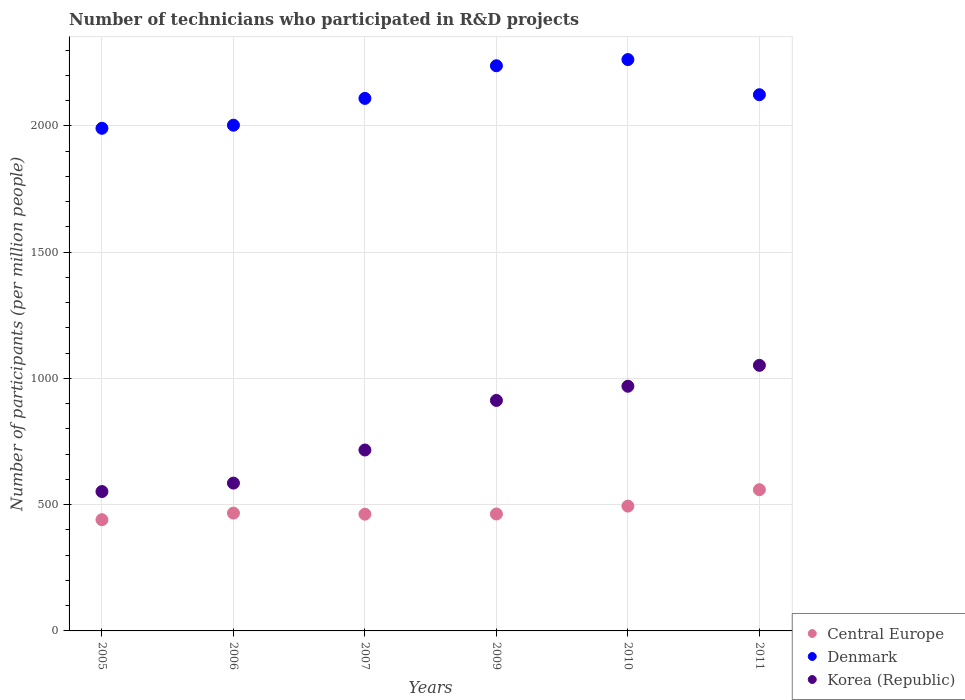How many different coloured dotlines are there?
Offer a terse response. 3. Is the number of dotlines equal to the number of legend labels?
Your response must be concise. Yes. What is the number of technicians who participated in R&D projects in Central Europe in 2006?
Keep it short and to the point. 466.5. Across all years, what is the maximum number of technicians who participated in R&D projects in Denmark?
Make the answer very short. 2262.1. Across all years, what is the minimum number of technicians who participated in R&D projects in Korea (Republic)?
Provide a succinct answer. 551.85. In which year was the number of technicians who participated in R&D projects in Denmark maximum?
Give a very brief answer. 2010. In which year was the number of technicians who participated in R&D projects in Korea (Republic) minimum?
Your answer should be very brief. 2005. What is the total number of technicians who participated in R&D projects in Korea (Republic) in the graph?
Your answer should be very brief. 4786.26. What is the difference between the number of technicians who participated in R&D projects in Korea (Republic) in 2005 and that in 2006?
Provide a succinct answer. -33.42. What is the difference between the number of technicians who participated in R&D projects in Central Europe in 2007 and the number of technicians who participated in R&D projects in Korea (Republic) in 2009?
Provide a short and direct response. -450.33. What is the average number of technicians who participated in R&D projects in Korea (Republic) per year?
Make the answer very short. 797.71. In the year 2006, what is the difference between the number of technicians who participated in R&D projects in Denmark and number of technicians who participated in R&D projects in Korea (Republic)?
Make the answer very short. 1417.02. What is the ratio of the number of technicians who participated in R&D projects in Central Europe in 2006 to that in 2009?
Your response must be concise. 1.01. Is the number of technicians who participated in R&D projects in Central Europe in 2005 less than that in 2009?
Ensure brevity in your answer.  Yes. What is the difference between the highest and the second highest number of technicians who participated in R&D projects in Denmark?
Make the answer very short. 24.47. What is the difference between the highest and the lowest number of technicians who participated in R&D projects in Central Europe?
Offer a terse response. 118.71. Is the sum of the number of technicians who participated in R&D projects in Korea (Republic) in 2007 and 2011 greater than the maximum number of technicians who participated in R&D projects in Denmark across all years?
Make the answer very short. No. Is the number of technicians who participated in R&D projects in Korea (Republic) strictly less than the number of technicians who participated in R&D projects in Denmark over the years?
Give a very brief answer. Yes. How many dotlines are there?
Your answer should be very brief. 3. How many years are there in the graph?
Offer a terse response. 6. What is the difference between two consecutive major ticks on the Y-axis?
Make the answer very short. 500. Does the graph contain any zero values?
Ensure brevity in your answer.  No. Does the graph contain grids?
Provide a short and direct response. Yes. Where does the legend appear in the graph?
Your answer should be very brief. Bottom right. How are the legend labels stacked?
Your answer should be very brief. Vertical. What is the title of the graph?
Your answer should be compact. Number of technicians who participated in R&D projects. Does "South Asia" appear as one of the legend labels in the graph?
Offer a terse response. No. What is the label or title of the Y-axis?
Give a very brief answer. Number of participants (per million people). What is the Number of participants (per million people) in Central Europe in 2005?
Make the answer very short. 440.38. What is the Number of participants (per million people) in Denmark in 2005?
Your answer should be compact. 1990.05. What is the Number of participants (per million people) of Korea (Republic) in 2005?
Ensure brevity in your answer.  551.85. What is the Number of participants (per million people) in Central Europe in 2006?
Provide a succinct answer. 466.5. What is the Number of participants (per million people) in Denmark in 2006?
Your response must be concise. 2002.29. What is the Number of participants (per million people) of Korea (Republic) in 2006?
Your response must be concise. 585.27. What is the Number of participants (per million people) in Central Europe in 2007?
Offer a terse response. 462.27. What is the Number of participants (per million people) of Denmark in 2007?
Your response must be concise. 2108.42. What is the Number of participants (per million people) of Korea (Republic) in 2007?
Provide a succinct answer. 716.3. What is the Number of participants (per million people) of Central Europe in 2009?
Offer a very short reply. 463.02. What is the Number of participants (per million people) in Denmark in 2009?
Make the answer very short. 2237.63. What is the Number of participants (per million people) of Korea (Republic) in 2009?
Give a very brief answer. 912.6. What is the Number of participants (per million people) in Central Europe in 2010?
Make the answer very short. 494.17. What is the Number of participants (per million people) of Denmark in 2010?
Offer a terse response. 2262.1. What is the Number of participants (per million people) of Korea (Republic) in 2010?
Your answer should be compact. 968.76. What is the Number of participants (per million people) in Central Europe in 2011?
Offer a very short reply. 559.09. What is the Number of participants (per million people) in Denmark in 2011?
Give a very brief answer. 2122.99. What is the Number of participants (per million people) in Korea (Republic) in 2011?
Ensure brevity in your answer.  1051.47. Across all years, what is the maximum Number of participants (per million people) of Central Europe?
Offer a very short reply. 559.09. Across all years, what is the maximum Number of participants (per million people) of Denmark?
Your answer should be very brief. 2262.1. Across all years, what is the maximum Number of participants (per million people) of Korea (Republic)?
Offer a terse response. 1051.47. Across all years, what is the minimum Number of participants (per million people) of Central Europe?
Give a very brief answer. 440.38. Across all years, what is the minimum Number of participants (per million people) of Denmark?
Your answer should be compact. 1990.05. Across all years, what is the minimum Number of participants (per million people) of Korea (Republic)?
Offer a terse response. 551.85. What is the total Number of participants (per million people) in Central Europe in the graph?
Keep it short and to the point. 2885.44. What is the total Number of participants (per million people) in Denmark in the graph?
Your response must be concise. 1.27e+04. What is the total Number of participants (per million people) of Korea (Republic) in the graph?
Offer a terse response. 4786.26. What is the difference between the Number of participants (per million people) of Central Europe in 2005 and that in 2006?
Your answer should be very brief. -26.13. What is the difference between the Number of participants (per million people) in Denmark in 2005 and that in 2006?
Offer a terse response. -12.24. What is the difference between the Number of participants (per million people) in Korea (Republic) in 2005 and that in 2006?
Ensure brevity in your answer.  -33.42. What is the difference between the Number of participants (per million people) of Central Europe in 2005 and that in 2007?
Ensure brevity in your answer.  -21.9. What is the difference between the Number of participants (per million people) in Denmark in 2005 and that in 2007?
Your response must be concise. -118.37. What is the difference between the Number of participants (per million people) of Korea (Republic) in 2005 and that in 2007?
Make the answer very short. -164.45. What is the difference between the Number of participants (per million people) in Central Europe in 2005 and that in 2009?
Your answer should be compact. -22.64. What is the difference between the Number of participants (per million people) of Denmark in 2005 and that in 2009?
Offer a very short reply. -247.57. What is the difference between the Number of participants (per million people) of Korea (Republic) in 2005 and that in 2009?
Ensure brevity in your answer.  -360.74. What is the difference between the Number of participants (per million people) in Central Europe in 2005 and that in 2010?
Keep it short and to the point. -53.79. What is the difference between the Number of participants (per million people) in Denmark in 2005 and that in 2010?
Make the answer very short. -272.04. What is the difference between the Number of participants (per million people) in Korea (Republic) in 2005 and that in 2010?
Your response must be concise. -416.91. What is the difference between the Number of participants (per million people) of Central Europe in 2005 and that in 2011?
Ensure brevity in your answer.  -118.71. What is the difference between the Number of participants (per million people) of Denmark in 2005 and that in 2011?
Give a very brief answer. -132.93. What is the difference between the Number of participants (per million people) of Korea (Republic) in 2005 and that in 2011?
Give a very brief answer. -499.62. What is the difference between the Number of participants (per million people) in Central Europe in 2006 and that in 2007?
Offer a very short reply. 4.23. What is the difference between the Number of participants (per million people) of Denmark in 2006 and that in 2007?
Offer a terse response. -106.13. What is the difference between the Number of participants (per million people) of Korea (Republic) in 2006 and that in 2007?
Make the answer very short. -131.03. What is the difference between the Number of participants (per million people) of Central Europe in 2006 and that in 2009?
Make the answer very short. 3.48. What is the difference between the Number of participants (per million people) in Denmark in 2006 and that in 2009?
Keep it short and to the point. -235.33. What is the difference between the Number of participants (per million people) in Korea (Republic) in 2006 and that in 2009?
Give a very brief answer. -327.33. What is the difference between the Number of participants (per million people) in Central Europe in 2006 and that in 2010?
Provide a short and direct response. -27.67. What is the difference between the Number of participants (per million people) in Denmark in 2006 and that in 2010?
Provide a succinct answer. -259.8. What is the difference between the Number of participants (per million people) in Korea (Republic) in 2006 and that in 2010?
Offer a very short reply. -383.49. What is the difference between the Number of participants (per million people) of Central Europe in 2006 and that in 2011?
Provide a short and direct response. -92.58. What is the difference between the Number of participants (per million people) of Denmark in 2006 and that in 2011?
Ensure brevity in your answer.  -120.69. What is the difference between the Number of participants (per million people) of Korea (Republic) in 2006 and that in 2011?
Give a very brief answer. -466.2. What is the difference between the Number of participants (per million people) in Central Europe in 2007 and that in 2009?
Ensure brevity in your answer.  -0.75. What is the difference between the Number of participants (per million people) of Denmark in 2007 and that in 2009?
Your response must be concise. -129.21. What is the difference between the Number of participants (per million people) in Korea (Republic) in 2007 and that in 2009?
Your answer should be compact. -196.3. What is the difference between the Number of participants (per million people) in Central Europe in 2007 and that in 2010?
Provide a short and direct response. -31.9. What is the difference between the Number of participants (per million people) of Denmark in 2007 and that in 2010?
Make the answer very short. -153.68. What is the difference between the Number of participants (per million people) of Korea (Republic) in 2007 and that in 2010?
Provide a short and direct response. -252.46. What is the difference between the Number of participants (per million people) of Central Europe in 2007 and that in 2011?
Make the answer very short. -96.82. What is the difference between the Number of participants (per million people) in Denmark in 2007 and that in 2011?
Provide a succinct answer. -14.57. What is the difference between the Number of participants (per million people) of Korea (Republic) in 2007 and that in 2011?
Ensure brevity in your answer.  -335.17. What is the difference between the Number of participants (per million people) in Central Europe in 2009 and that in 2010?
Provide a succinct answer. -31.15. What is the difference between the Number of participants (per million people) of Denmark in 2009 and that in 2010?
Offer a very short reply. -24.47. What is the difference between the Number of participants (per million people) in Korea (Republic) in 2009 and that in 2010?
Provide a short and direct response. -56.16. What is the difference between the Number of participants (per million people) of Central Europe in 2009 and that in 2011?
Your answer should be compact. -96.07. What is the difference between the Number of participants (per million people) in Denmark in 2009 and that in 2011?
Make the answer very short. 114.64. What is the difference between the Number of participants (per million people) in Korea (Republic) in 2009 and that in 2011?
Make the answer very short. -138.87. What is the difference between the Number of participants (per million people) in Central Europe in 2010 and that in 2011?
Provide a succinct answer. -64.92. What is the difference between the Number of participants (per million people) of Denmark in 2010 and that in 2011?
Provide a succinct answer. 139.11. What is the difference between the Number of participants (per million people) in Korea (Republic) in 2010 and that in 2011?
Provide a short and direct response. -82.71. What is the difference between the Number of participants (per million people) in Central Europe in 2005 and the Number of participants (per million people) in Denmark in 2006?
Your answer should be compact. -1561.91. What is the difference between the Number of participants (per million people) of Central Europe in 2005 and the Number of participants (per million people) of Korea (Republic) in 2006?
Your answer should be compact. -144.9. What is the difference between the Number of participants (per million people) of Denmark in 2005 and the Number of participants (per million people) of Korea (Republic) in 2006?
Ensure brevity in your answer.  1404.78. What is the difference between the Number of participants (per million people) of Central Europe in 2005 and the Number of participants (per million people) of Denmark in 2007?
Ensure brevity in your answer.  -1668.04. What is the difference between the Number of participants (per million people) in Central Europe in 2005 and the Number of participants (per million people) in Korea (Republic) in 2007?
Offer a terse response. -275.92. What is the difference between the Number of participants (per million people) of Denmark in 2005 and the Number of participants (per million people) of Korea (Republic) in 2007?
Offer a very short reply. 1273.75. What is the difference between the Number of participants (per million people) in Central Europe in 2005 and the Number of participants (per million people) in Denmark in 2009?
Give a very brief answer. -1797.25. What is the difference between the Number of participants (per million people) in Central Europe in 2005 and the Number of participants (per million people) in Korea (Republic) in 2009?
Make the answer very short. -472.22. What is the difference between the Number of participants (per million people) of Denmark in 2005 and the Number of participants (per million people) of Korea (Republic) in 2009?
Offer a terse response. 1077.45. What is the difference between the Number of participants (per million people) of Central Europe in 2005 and the Number of participants (per million people) of Denmark in 2010?
Your answer should be very brief. -1821.72. What is the difference between the Number of participants (per million people) in Central Europe in 2005 and the Number of participants (per million people) in Korea (Republic) in 2010?
Keep it short and to the point. -528.38. What is the difference between the Number of participants (per million people) in Denmark in 2005 and the Number of participants (per million people) in Korea (Republic) in 2010?
Your response must be concise. 1021.29. What is the difference between the Number of participants (per million people) of Central Europe in 2005 and the Number of participants (per million people) of Denmark in 2011?
Your answer should be very brief. -1682.61. What is the difference between the Number of participants (per million people) in Central Europe in 2005 and the Number of participants (per million people) in Korea (Republic) in 2011?
Ensure brevity in your answer.  -611.1. What is the difference between the Number of participants (per million people) in Denmark in 2005 and the Number of participants (per million people) in Korea (Republic) in 2011?
Make the answer very short. 938.58. What is the difference between the Number of participants (per million people) of Central Europe in 2006 and the Number of participants (per million people) of Denmark in 2007?
Your response must be concise. -1641.92. What is the difference between the Number of participants (per million people) in Central Europe in 2006 and the Number of participants (per million people) in Korea (Republic) in 2007?
Offer a terse response. -249.8. What is the difference between the Number of participants (per million people) in Denmark in 2006 and the Number of participants (per million people) in Korea (Republic) in 2007?
Provide a short and direct response. 1285.99. What is the difference between the Number of participants (per million people) in Central Europe in 2006 and the Number of participants (per million people) in Denmark in 2009?
Provide a short and direct response. -1771.12. What is the difference between the Number of participants (per million people) of Central Europe in 2006 and the Number of participants (per million people) of Korea (Republic) in 2009?
Keep it short and to the point. -446.09. What is the difference between the Number of participants (per million people) of Denmark in 2006 and the Number of participants (per million people) of Korea (Republic) in 2009?
Your answer should be compact. 1089.69. What is the difference between the Number of participants (per million people) in Central Europe in 2006 and the Number of participants (per million people) in Denmark in 2010?
Your answer should be compact. -1795.59. What is the difference between the Number of participants (per million people) in Central Europe in 2006 and the Number of participants (per million people) in Korea (Republic) in 2010?
Ensure brevity in your answer.  -502.26. What is the difference between the Number of participants (per million people) in Denmark in 2006 and the Number of participants (per million people) in Korea (Republic) in 2010?
Your answer should be compact. 1033.53. What is the difference between the Number of participants (per million people) in Central Europe in 2006 and the Number of participants (per million people) in Denmark in 2011?
Ensure brevity in your answer.  -1656.48. What is the difference between the Number of participants (per million people) of Central Europe in 2006 and the Number of participants (per million people) of Korea (Republic) in 2011?
Offer a very short reply. -584.97. What is the difference between the Number of participants (per million people) of Denmark in 2006 and the Number of participants (per million people) of Korea (Republic) in 2011?
Offer a very short reply. 950.82. What is the difference between the Number of participants (per million people) of Central Europe in 2007 and the Number of participants (per million people) of Denmark in 2009?
Ensure brevity in your answer.  -1775.35. What is the difference between the Number of participants (per million people) in Central Europe in 2007 and the Number of participants (per million people) in Korea (Republic) in 2009?
Your response must be concise. -450.33. What is the difference between the Number of participants (per million people) in Denmark in 2007 and the Number of participants (per million people) in Korea (Republic) in 2009?
Give a very brief answer. 1195.82. What is the difference between the Number of participants (per million people) in Central Europe in 2007 and the Number of participants (per million people) in Denmark in 2010?
Your response must be concise. -1799.82. What is the difference between the Number of participants (per million people) of Central Europe in 2007 and the Number of participants (per million people) of Korea (Republic) in 2010?
Your answer should be very brief. -506.49. What is the difference between the Number of participants (per million people) of Denmark in 2007 and the Number of participants (per million people) of Korea (Republic) in 2010?
Ensure brevity in your answer.  1139.66. What is the difference between the Number of participants (per million people) of Central Europe in 2007 and the Number of participants (per million people) of Denmark in 2011?
Provide a short and direct response. -1660.71. What is the difference between the Number of participants (per million people) of Central Europe in 2007 and the Number of participants (per million people) of Korea (Republic) in 2011?
Offer a terse response. -589.2. What is the difference between the Number of participants (per million people) in Denmark in 2007 and the Number of participants (per million people) in Korea (Republic) in 2011?
Ensure brevity in your answer.  1056.95. What is the difference between the Number of participants (per million people) of Central Europe in 2009 and the Number of participants (per million people) of Denmark in 2010?
Your answer should be compact. -1799.07. What is the difference between the Number of participants (per million people) in Central Europe in 2009 and the Number of participants (per million people) in Korea (Republic) in 2010?
Offer a very short reply. -505.74. What is the difference between the Number of participants (per million people) in Denmark in 2009 and the Number of participants (per million people) in Korea (Republic) in 2010?
Make the answer very short. 1268.86. What is the difference between the Number of participants (per million people) of Central Europe in 2009 and the Number of participants (per million people) of Denmark in 2011?
Keep it short and to the point. -1659.96. What is the difference between the Number of participants (per million people) in Central Europe in 2009 and the Number of participants (per million people) in Korea (Republic) in 2011?
Your response must be concise. -588.45. What is the difference between the Number of participants (per million people) of Denmark in 2009 and the Number of participants (per million people) of Korea (Republic) in 2011?
Provide a short and direct response. 1186.15. What is the difference between the Number of participants (per million people) in Central Europe in 2010 and the Number of participants (per million people) in Denmark in 2011?
Make the answer very short. -1628.82. What is the difference between the Number of participants (per million people) in Central Europe in 2010 and the Number of participants (per million people) in Korea (Republic) in 2011?
Your answer should be very brief. -557.3. What is the difference between the Number of participants (per million people) of Denmark in 2010 and the Number of participants (per million people) of Korea (Republic) in 2011?
Make the answer very short. 1210.62. What is the average Number of participants (per million people) in Central Europe per year?
Offer a terse response. 480.91. What is the average Number of participants (per million people) in Denmark per year?
Give a very brief answer. 2120.58. What is the average Number of participants (per million people) in Korea (Republic) per year?
Make the answer very short. 797.71. In the year 2005, what is the difference between the Number of participants (per million people) in Central Europe and Number of participants (per million people) in Denmark?
Make the answer very short. -1549.68. In the year 2005, what is the difference between the Number of participants (per million people) in Central Europe and Number of participants (per million people) in Korea (Republic)?
Your answer should be very brief. -111.48. In the year 2005, what is the difference between the Number of participants (per million people) in Denmark and Number of participants (per million people) in Korea (Republic)?
Ensure brevity in your answer.  1438.2. In the year 2006, what is the difference between the Number of participants (per million people) of Central Europe and Number of participants (per million people) of Denmark?
Make the answer very short. -1535.79. In the year 2006, what is the difference between the Number of participants (per million people) in Central Europe and Number of participants (per million people) in Korea (Republic)?
Your response must be concise. -118.77. In the year 2006, what is the difference between the Number of participants (per million people) of Denmark and Number of participants (per million people) of Korea (Republic)?
Give a very brief answer. 1417.02. In the year 2007, what is the difference between the Number of participants (per million people) of Central Europe and Number of participants (per million people) of Denmark?
Offer a terse response. -1646.15. In the year 2007, what is the difference between the Number of participants (per million people) in Central Europe and Number of participants (per million people) in Korea (Republic)?
Keep it short and to the point. -254.03. In the year 2007, what is the difference between the Number of participants (per million people) of Denmark and Number of participants (per million people) of Korea (Republic)?
Offer a very short reply. 1392.12. In the year 2009, what is the difference between the Number of participants (per million people) of Central Europe and Number of participants (per million people) of Denmark?
Keep it short and to the point. -1774.6. In the year 2009, what is the difference between the Number of participants (per million people) in Central Europe and Number of participants (per million people) in Korea (Republic)?
Give a very brief answer. -449.58. In the year 2009, what is the difference between the Number of participants (per million people) of Denmark and Number of participants (per million people) of Korea (Republic)?
Your response must be concise. 1325.03. In the year 2010, what is the difference between the Number of participants (per million people) in Central Europe and Number of participants (per million people) in Denmark?
Ensure brevity in your answer.  -1767.93. In the year 2010, what is the difference between the Number of participants (per million people) of Central Europe and Number of participants (per million people) of Korea (Republic)?
Your answer should be compact. -474.59. In the year 2010, what is the difference between the Number of participants (per million people) of Denmark and Number of participants (per million people) of Korea (Republic)?
Ensure brevity in your answer.  1293.33. In the year 2011, what is the difference between the Number of participants (per million people) in Central Europe and Number of participants (per million people) in Denmark?
Provide a succinct answer. -1563.9. In the year 2011, what is the difference between the Number of participants (per million people) in Central Europe and Number of participants (per million people) in Korea (Republic)?
Your answer should be very brief. -492.38. In the year 2011, what is the difference between the Number of participants (per million people) of Denmark and Number of participants (per million people) of Korea (Republic)?
Make the answer very short. 1071.51. What is the ratio of the Number of participants (per million people) in Central Europe in 2005 to that in 2006?
Your answer should be compact. 0.94. What is the ratio of the Number of participants (per million people) of Korea (Republic) in 2005 to that in 2006?
Give a very brief answer. 0.94. What is the ratio of the Number of participants (per million people) of Central Europe in 2005 to that in 2007?
Offer a very short reply. 0.95. What is the ratio of the Number of participants (per million people) in Denmark in 2005 to that in 2007?
Provide a short and direct response. 0.94. What is the ratio of the Number of participants (per million people) in Korea (Republic) in 2005 to that in 2007?
Your response must be concise. 0.77. What is the ratio of the Number of participants (per million people) in Central Europe in 2005 to that in 2009?
Your response must be concise. 0.95. What is the ratio of the Number of participants (per million people) of Denmark in 2005 to that in 2009?
Offer a very short reply. 0.89. What is the ratio of the Number of participants (per million people) in Korea (Republic) in 2005 to that in 2009?
Make the answer very short. 0.6. What is the ratio of the Number of participants (per million people) in Central Europe in 2005 to that in 2010?
Make the answer very short. 0.89. What is the ratio of the Number of participants (per million people) of Denmark in 2005 to that in 2010?
Make the answer very short. 0.88. What is the ratio of the Number of participants (per million people) in Korea (Republic) in 2005 to that in 2010?
Provide a succinct answer. 0.57. What is the ratio of the Number of participants (per million people) of Central Europe in 2005 to that in 2011?
Provide a succinct answer. 0.79. What is the ratio of the Number of participants (per million people) in Denmark in 2005 to that in 2011?
Your answer should be compact. 0.94. What is the ratio of the Number of participants (per million people) of Korea (Republic) in 2005 to that in 2011?
Provide a short and direct response. 0.52. What is the ratio of the Number of participants (per million people) of Central Europe in 2006 to that in 2007?
Make the answer very short. 1.01. What is the ratio of the Number of participants (per million people) of Denmark in 2006 to that in 2007?
Provide a short and direct response. 0.95. What is the ratio of the Number of participants (per million people) of Korea (Republic) in 2006 to that in 2007?
Your response must be concise. 0.82. What is the ratio of the Number of participants (per million people) in Central Europe in 2006 to that in 2009?
Your answer should be very brief. 1.01. What is the ratio of the Number of participants (per million people) of Denmark in 2006 to that in 2009?
Keep it short and to the point. 0.89. What is the ratio of the Number of participants (per million people) in Korea (Republic) in 2006 to that in 2009?
Offer a very short reply. 0.64. What is the ratio of the Number of participants (per million people) in Central Europe in 2006 to that in 2010?
Provide a short and direct response. 0.94. What is the ratio of the Number of participants (per million people) of Denmark in 2006 to that in 2010?
Provide a succinct answer. 0.89. What is the ratio of the Number of participants (per million people) in Korea (Republic) in 2006 to that in 2010?
Keep it short and to the point. 0.6. What is the ratio of the Number of participants (per million people) in Central Europe in 2006 to that in 2011?
Ensure brevity in your answer.  0.83. What is the ratio of the Number of participants (per million people) in Denmark in 2006 to that in 2011?
Keep it short and to the point. 0.94. What is the ratio of the Number of participants (per million people) in Korea (Republic) in 2006 to that in 2011?
Keep it short and to the point. 0.56. What is the ratio of the Number of participants (per million people) in Central Europe in 2007 to that in 2009?
Your answer should be compact. 1. What is the ratio of the Number of participants (per million people) in Denmark in 2007 to that in 2009?
Ensure brevity in your answer.  0.94. What is the ratio of the Number of participants (per million people) of Korea (Republic) in 2007 to that in 2009?
Provide a succinct answer. 0.78. What is the ratio of the Number of participants (per million people) of Central Europe in 2007 to that in 2010?
Offer a very short reply. 0.94. What is the ratio of the Number of participants (per million people) in Denmark in 2007 to that in 2010?
Offer a very short reply. 0.93. What is the ratio of the Number of participants (per million people) of Korea (Republic) in 2007 to that in 2010?
Keep it short and to the point. 0.74. What is the ratio of the Number of participants (per million people) in Central Europe in 2007 to that in 2011?
Ensure brevity in your answer.  0.83. What is the ratio of the Number of participants (per million people) in Denmark in 2007 to that in 2011?
Make the answer very short. 0.99. What is the ratio of the Number of participants (per million people) of Korea (Republic) in 2007 to that in 2011?
Your answer should be very brief. 0.68. What is the ratio of the Number of participants (per million people) in Central Europe in 2009 to that in 2010?
Provide a succinct answer. 0.94. What is the ratio of the Number of participants (per million people) in Korea (Republic) in 2009 to that in 2010?
Offer a terse response. 0.94. What is the ratio of the Number of participants (per million people) in Central Europe in 2009 to that in 2011?
Provide a succinct answer. 0.83. What is the ratio of the Number of participants (per million people) in Denmark in 2009 to that in 2011?
Ensure brevity in your answer.  1.05. What is the ratio of the Number of participants (per million people) of Korea (Republic) in 2009 to that in 2011?
Keep it short and to the point. 0.87. What is the ratio of the Number of participants (per million people) in Central Europe in 2010 to that in 2011?
Ensure brevity in your answer.  0.88. What is the ratio of the Number of participants (per million people) of Denmark in 2010 to that in 2011?
Provide a succinct answer. 1.07. What is the ratio of the Number of participants (per million people) in Korea (Republic) in 2010 to that in 2011?
Provide a short and direct response. 0.92. What is the difference between the highest and the second highest Number of participants (per million people) in Central Europe?
Your response must be concise. 64.92. What is the difference between the highest and the second highest Number of participants (per million people) in Denmark?
Your answer should be compact. 24.47. What is the difference between the highest and the second highest Number of participants (per million people) in Korea (Republic)?
Your answer should be very brief. 82.71. What is the difference between the highest and the lowest Number of participants (per million people) in Central Europe?
Offer a very short reply. 118.71. What is the difference between the highest and the lowest Number of participants (per million people) of Denmark?
Provide a short and direct response. 272.04. What is the difference between the highest and the lowest Number of participants (per million people) in Korea (Republic)?
Your response must be concise. 499.62. 